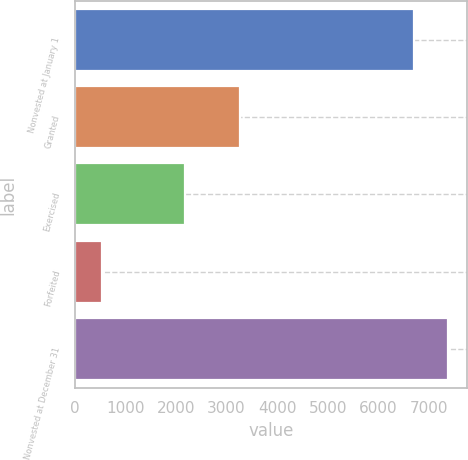Convert chart to OTSL. <chart><loc_0><loc_0><loc_500><loc_500><bar_chart><fcel>Nonvested at January 1<fcel>Granted<fcel>Exercised<fcel>Forfeited<fcel>Nonvested at December 31<nl><fcel>6710<fcel>3264<fcel>2183<fcel>538<fcel>7381.5<nl></chart> 